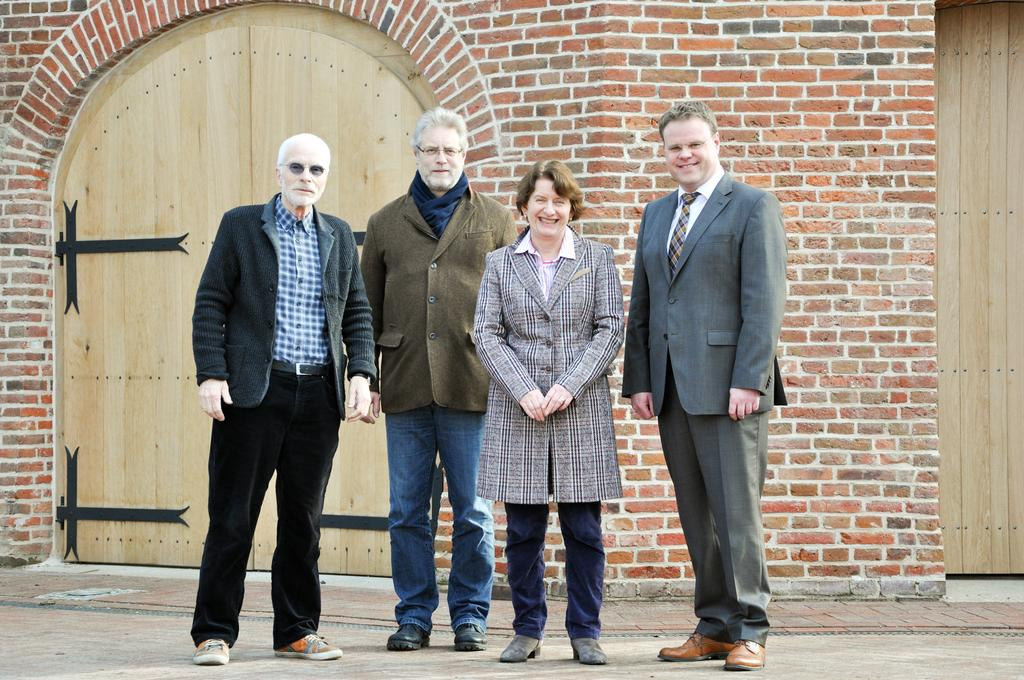How many people are present in the image? There are four people standing on the road. What is the facial expression of the people in the image? The people are smiling. What type of building can be seen in the background? There is a building with red bricks in the background. What architectural feature is present in the background? There are two wooden doors in the background. What type of paper can be seen blowing in the wind in the image? There is no paper blowing in the wind in the image. 